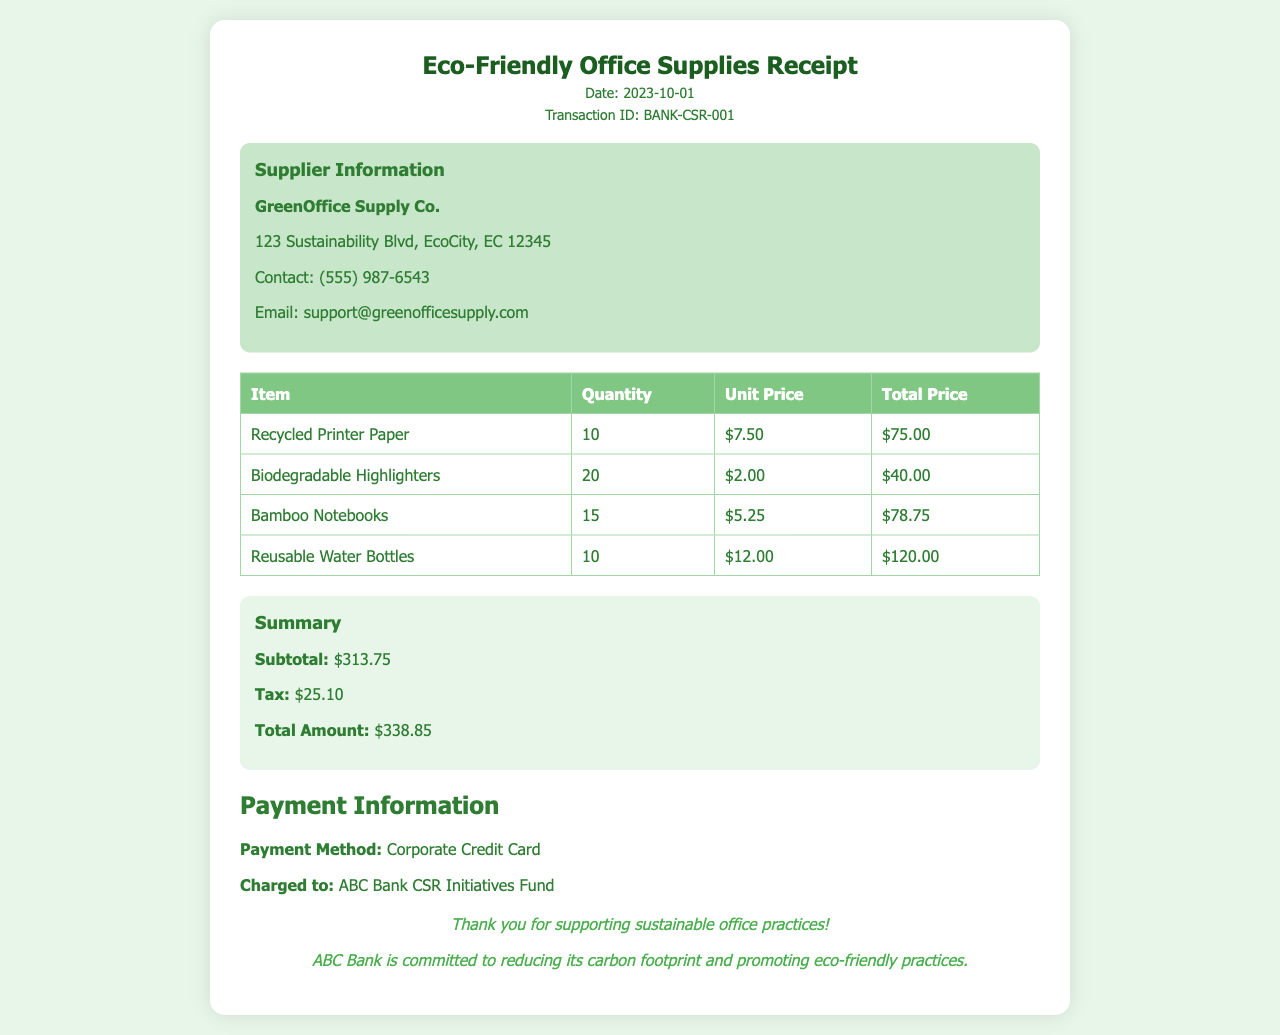What is the date of the receipt? The date of the receipt is listed at the top of the document, which is 2023-10-01.
Answer: 2023-10-01 Who is the supplier of the office supplies? The supplier's name is indicated in the supplier information section of the document, which is GreenOffice Supply Co.
Answer: GreenOffice Supply Co What is the total amount spent on the purchase? The total amount can be found in the summary section, which states that the total amount is $338.85.
Answer: $338.85 How many recycled printer papers were purchased? The quantity for recycled printer paper is specified in the items table, which shows that 10 were purchased.
Answer: 10 What payment method was used for this transaction? The payment method is mentioned in the payment information section, which states it was a Corporate Credit Card.
Answer: Corporate Credit Card Which item had the highest total price? By comparing the total prices in the items table, it is clear that the Reusable Water Bottles had the highest total price of $120.00.
Answer: Reusable Water Bottles What is the subtotal amount before tax? The subtotal amount is referenced in the summary section of the document, which is $313.75.
Answer: $313.75 What email address is provided for the supplier? The contact information for the supplier, including email, is given in the supplier info section, specifically as support@greenofficesupply.com.
Answer: support@greenofficesupply.com Which item is categorized as biodegradable? In the items table, Biodegradable Highlighters is indicated as the item categorized as biodegradable.
Answer: Biodegradable Highlighters 